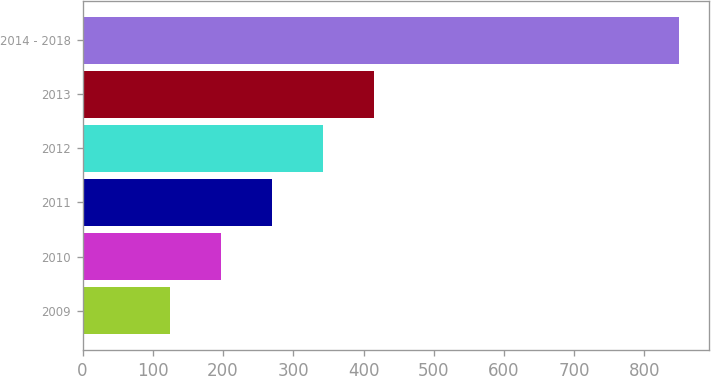Convert chart to OTSL. <chart><loc_0><loc_0><loc_500><loc_500><bar_chart><fcel>2009<fcel>2010<fcel>2011<fcel>2012<fcel>2013<fcel>2014 - 2018<nl><fcel>124.6<fcel>197.13<fcel>269.66<fcel>342.19<fcel>414.72<fcel>849.9<nl></chart> 